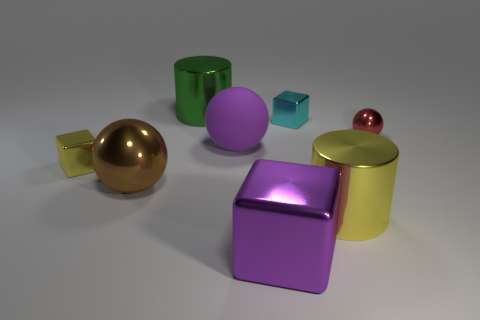Subtract 1 blocks. How many blocks are left? 2 Add 1 red shiny objects. How many objects exist? 9 Subtract all balls. How many objects are left? 5 Add 8 big purple spheres. How many big purple spheres are left? 9 Add 6 large purple shiny blocks. How many large purple shiny blocks exist? 7 Subtract 0 green balls. How many objects are left? 8 Subtract all big gray things. Subtract all big yellow objects. How many objects are left? 7 